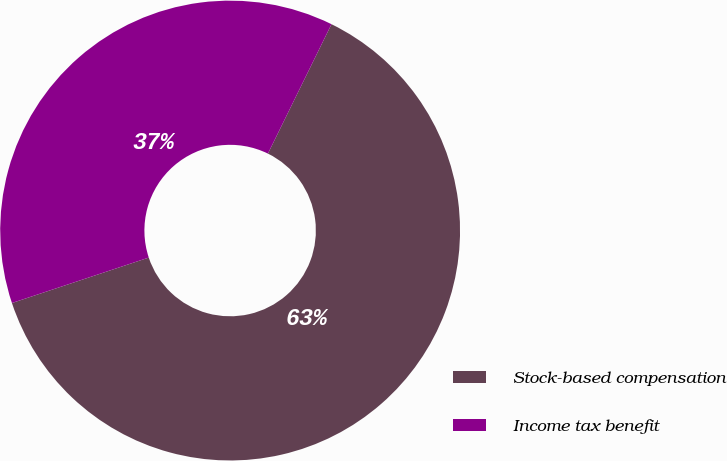<chart> <loc_0><loc_0><loc_500><loc_500><pie_chart><fcel>Stock-based compensation<fcel>Income tax benefit<nl><fcel>62.63%<fcel>37.37%<nl></chart> 